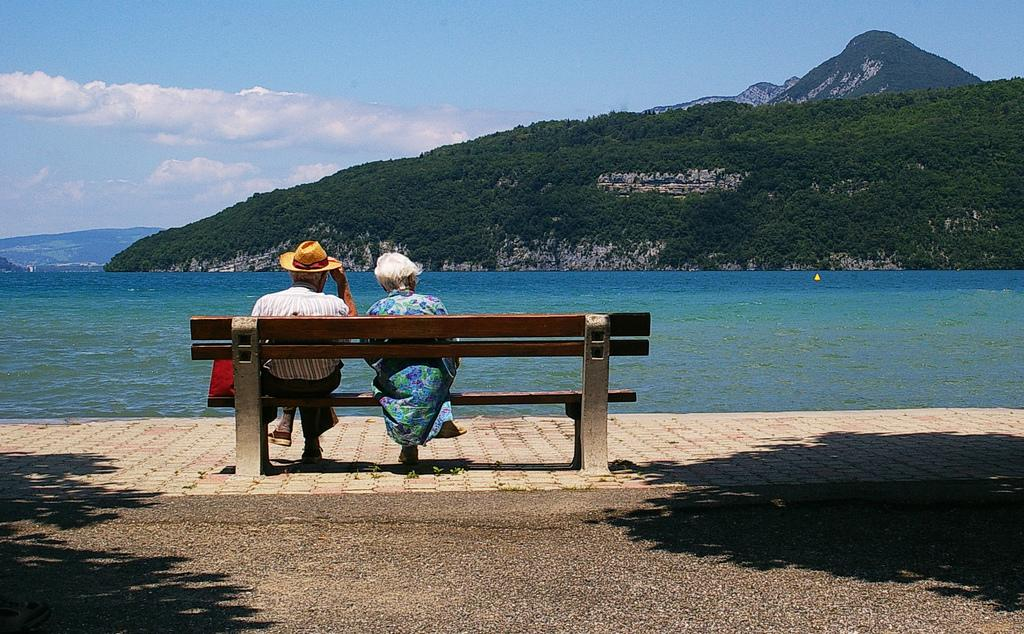How many people are sitting in the desk in the image? There are two people sitting in a desk in the image. What type of scenery can be seen in the image? There is a scenic beauty of mountains in the image, as well as a sea visible. Can you describe the setting of the image? The image features a desk with two people sitting in it, and the background includes mountains and a sea. What type of cable can be seen connecting the mountains in the image? There is no cable visible in the image; it only features a scenic view of mountains and a sea. 